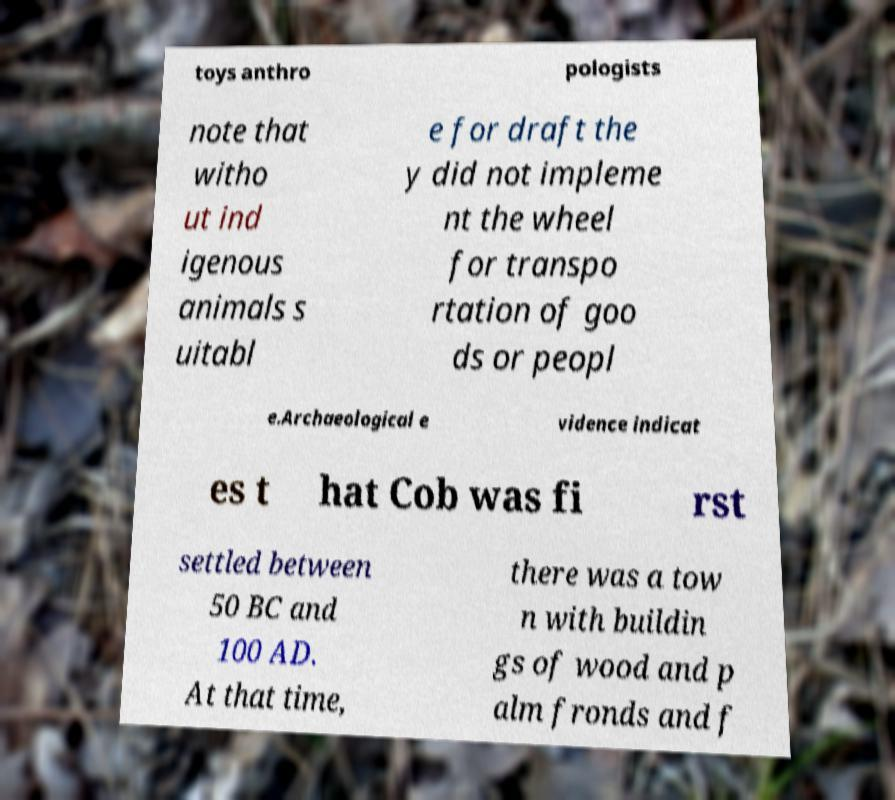Can you read and provide the text displayed in the image?This photo seems to have some interesting text. Can you extract and type it out for me? toys anthro pologists note that witho ut ind igenous animals s uitabl e for draft the y did not impleme nt the wheel for transpo rtation of goo ds or peopl e.Archaeological e vidence indicat es t hat Cob was fi rst settled between 50 BC and 100 AD. At that time, there was a tow n with buildin gs of wood and p alm fronds and f 